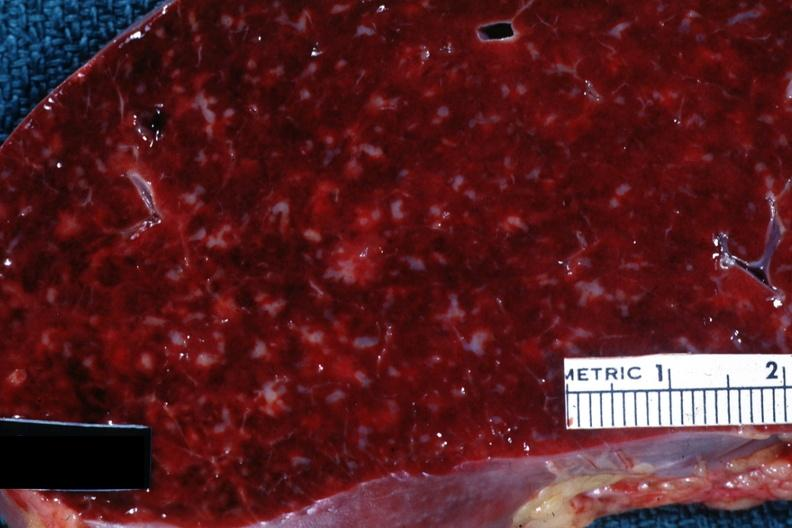s mucinous cystadenocarcinoma present?
Answer the question using a single word or phrase. No 